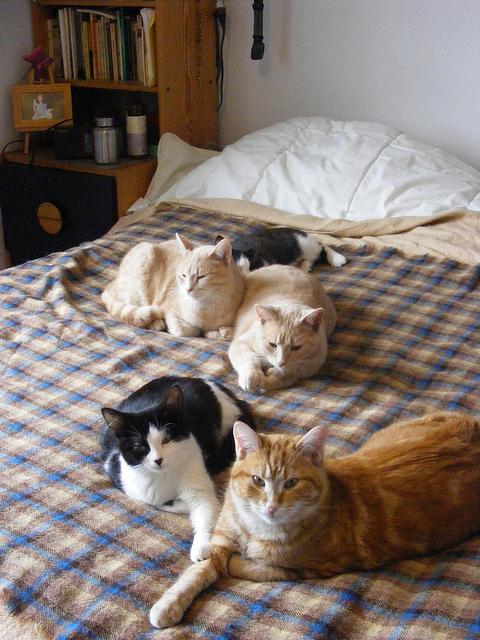What types of animals are on the bed?
Short answer required. Cats. How many cats are on the bed?
Short answer required. 5. Are the two closest cats touching?
Concise answer only. Yes. 